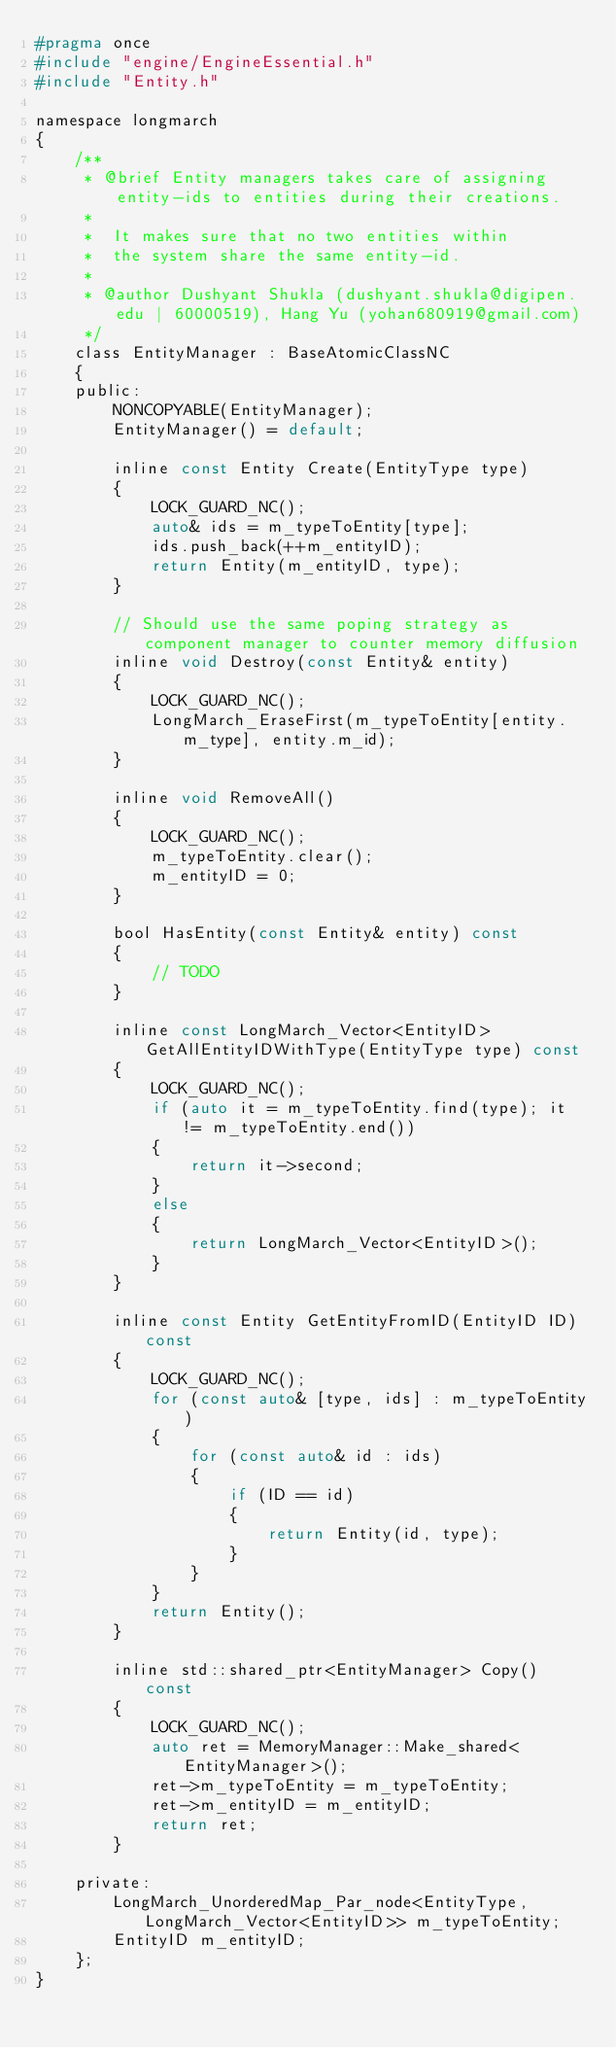Convert code to text. <code><loc_0><loc_0><loc_500><loc_500><_C_>#pragma once
#include "engine/EngineEssential.h"
#include "Entity.h"

namespace longmarch
{
	/**
	 * @brief Entity managers takes care of assigning entity-ids to entities during their creations.
	 *
	 *  It makes sure that no two entities within
	 *	the system share the same entity-id.
	 *
	 * @author Dushyant Shukla (dushyant.shukla@digipen.edu | 60000519), Hang Yu (yohan680919@gmail.com)
	 */
	class EntityManager : BaseAtomicClassNC
	{
	public:
		NONCOPYABLE(EntityManager);
		EntityManager() = default;

		inline const Entity Create(EntityType type)
		{
			LOCK_GUARD_NC();
			auto& ids = m_typeToEntity[type];
			ids.push_back(++m_entityID);
			return Entity(m_entityID, type);
		}

		// Should use the same poping strategy as component manager to counter memory diffusion
		inline void Destroy(const Entity& entity)
		{
			LOCK_GUARD_NC();
			LongMarch_EraseFirst(m_typeToEntity[entity.m_type], entity.m_id);
		}

		inline void RemoveAll()
		{
			LOCK_GUARD_NC();
			m_typeToEntity.clear();
			m_entityID = 0;
		}

		bool HasEntity(const Entity& entity) const
		{
			// TODO
		}

		inline const LongMarch_Vector<EntityID> GetAllEntityIDWithType(EntityType type) const
		{
			LOCK_GUARD_NC();
			if (auto it = m_typeToEntity.find(type); it != m_typeToEntity.end())
			{
				return it->second;
			}
			else
			{
				return LongMarch_Vector<EntityID>();
			}
		}

		inline const Entity GetEntityFromID(EntityID ID) const
		{
			LOCK_GUARD_NC();
			for (const auto& [type, ids] : m_typeToEntity)
			{
				for (const auto& id : ids)
				{
					if (ID == id)
					{
						return Entity(id, type);
					}
				}
			}
			return Entity();
		}

		inline std::shared_ptr<EntityManager> Copy() const
		{
			LOCK_GUARD_NC();
			auto ret = MemoryManager::Make_shared<EntityManager>();
			ret->m_typeToEntity = m_typeToEntity;
			ret->m_entityID = m_entityID;
			return ret;
		}

	private:
		LongMarch_UnorderedMap_Par_node<EntityType, LongMarch_Vector<EntityID>> m_typeToEntity;
		EntityID m_entityID;
	};
}
</code> 